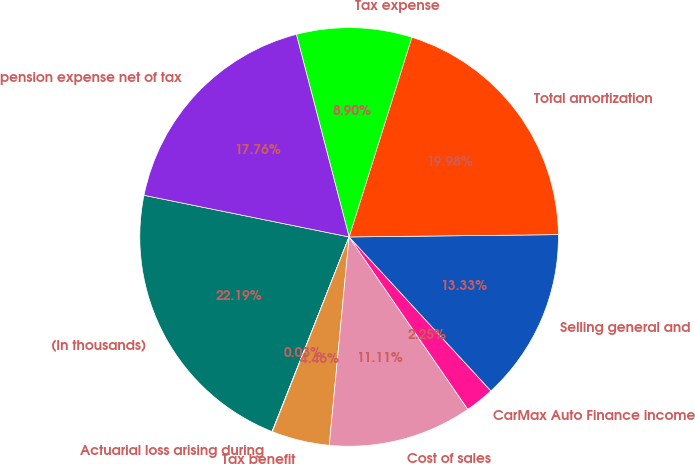Convert chart to OTSL. <chart><loc_0><loc_0><loc_500><loc_500><pie_chart><fcel>(In thousands)<fcel>Actuarial loss arising during<fcel>Tax benefit<fcel>Cost of sales<fcel>CarMax Auto Finance income<fcel>Selling general and<fcel>Total amortization<fcel>Tax expense<fcel>pension expense net of tax<nl><fcel>22.19%<fcel>0.03%<fcel>4.46%<fcel>11.11%<fcel>2.25%<fcel>13.33%<fcel>19.98%<fcel>8.9%<fcel>17.76%<nl></chart> 